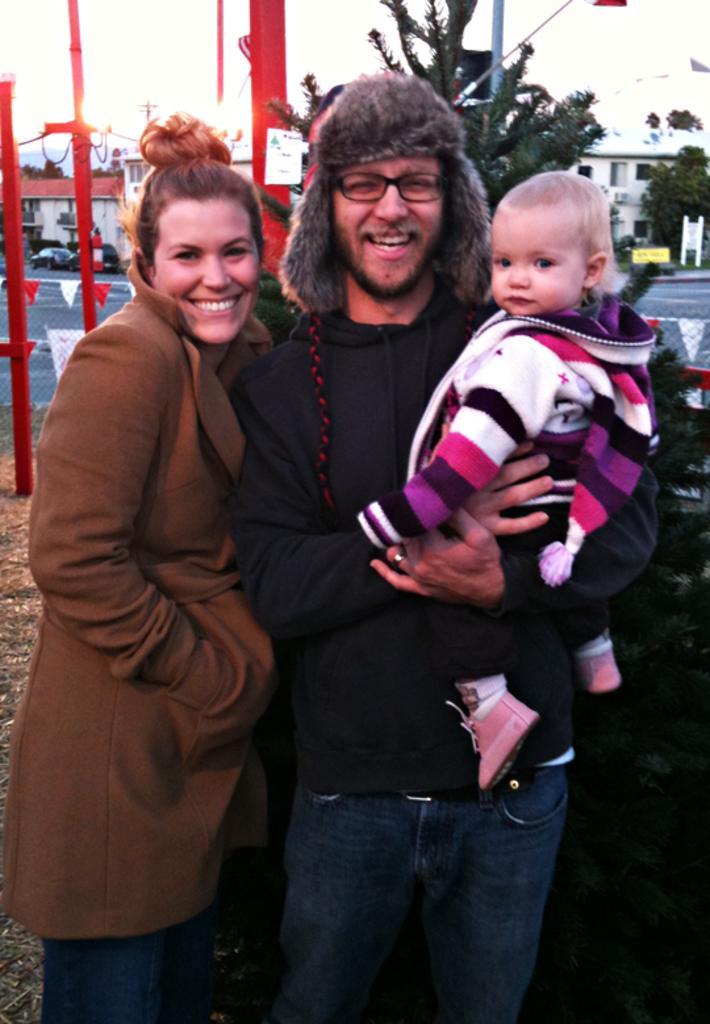In one or two sentences, can you explain what this image depicts? In center of the image there is a person carrying a baby. Beside him there is a lady wearing a coat. In the background of the image there are trees,buildings. To the right side of the image there is a car. 